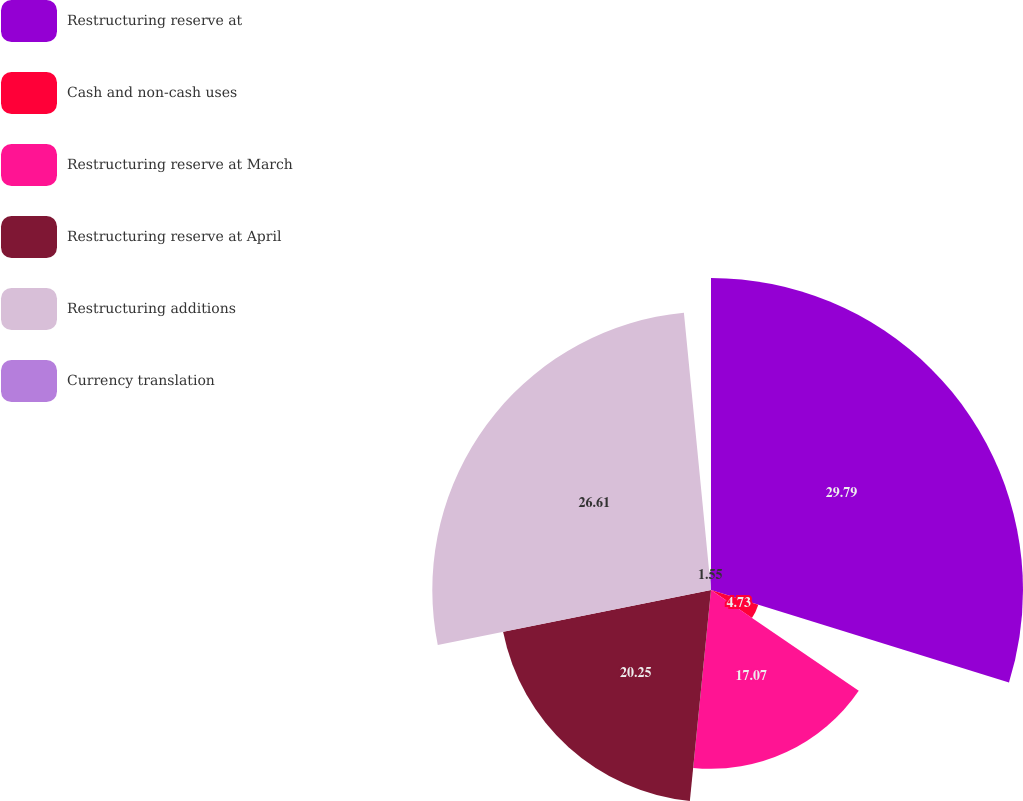Convert chart to OTSL. <chart><loc_0><loc_0><loc_500><loc_500><pie_chart><fcel>Restructuring reserve at<fcel>Cash and non-cash uses<fcel>Restructuring reserve at March<fcel>Restructuring reserve at April<fcel>Restructuring additions<fcel>Currency translation<nl><fcel>29.79%<fcel>4.73%<fcel>17.07%<fcel>20.25%<fcel>26.61%<fcel>1.55%<nl></chart> 